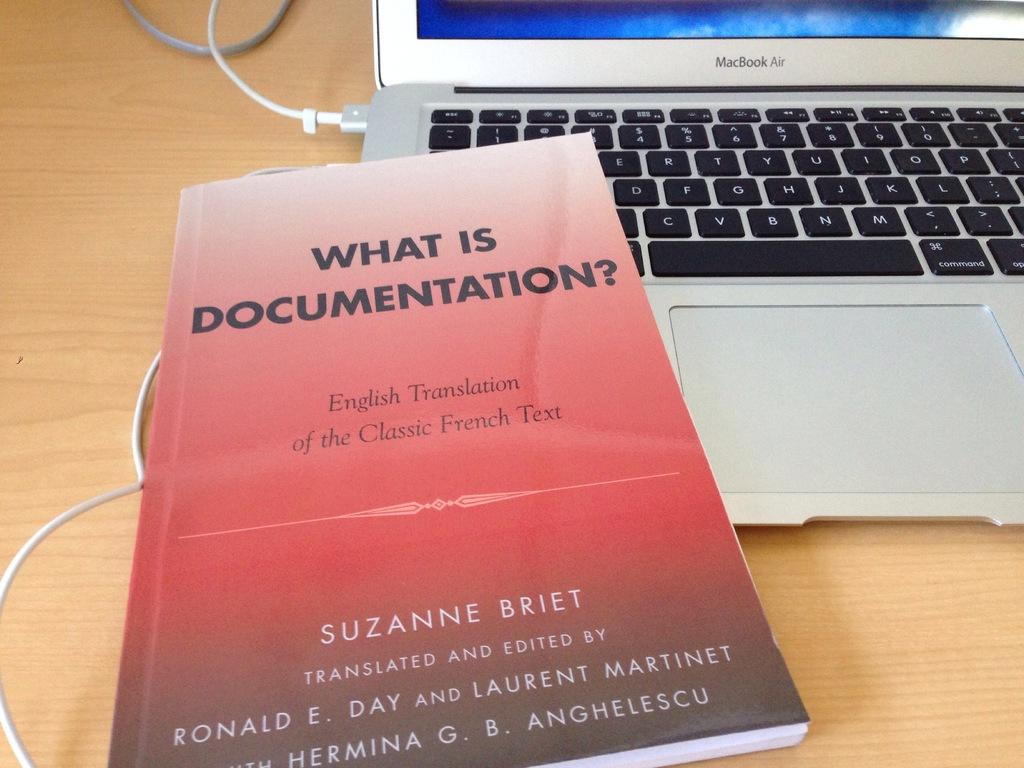<image>
Present a compact description of the photo's key features. A book with a red cover laying on a a laptop called "What is documentation?" 